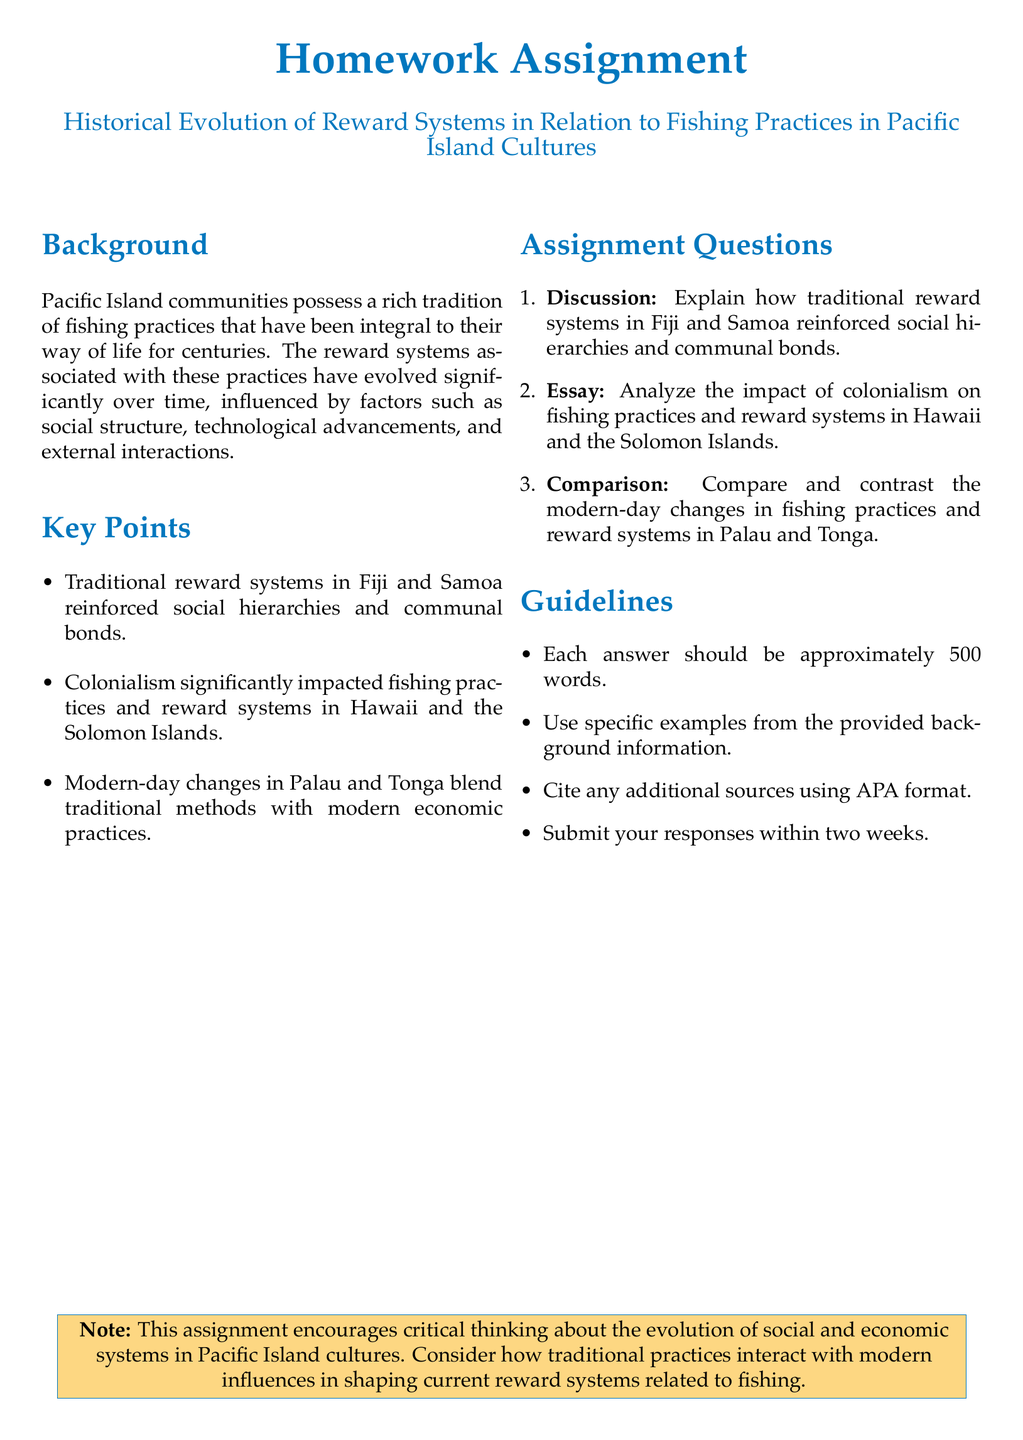What is the title of the homework assignment? The title of the homework assignment is stated in the document.
Answer: Historical Evolution of Reward Systems in Relation to Fishing Practices in Pacific Island Cultures How many key points are listed in the document? The document contains a specific number of key points that summarize important aspects.
Answer: Three What countries are mentioned regarding traditional reward systems? The document specifies traditional reward systems related to specific Pacific Island countries.
Answer: Fiji and Samoa What has significantly impacted fishing practices in Hawaii and the Solomon Islands? The document identifies a historical factor that affected fishing practices and reward systems.
Answer: Colonialism What is the expected word count for each answer? The document indicates a specific length requirement for the assignments.
Answer: Approximately 500 words In which two countries are modern-day changes in fishing practices compared? The document establishes a comparison between two Pacific Islands regarding modern changes.
Answer: Palau and Tonga What type of analysis is required for the second question in the assignment? The type of analysis for the second question pertains to a historical influence on practices and systems.
Answer: Analyze How long is the completion timeframe for the assignment? The document specifies a period for submitting the assignments.
Answer: Within two weeks 